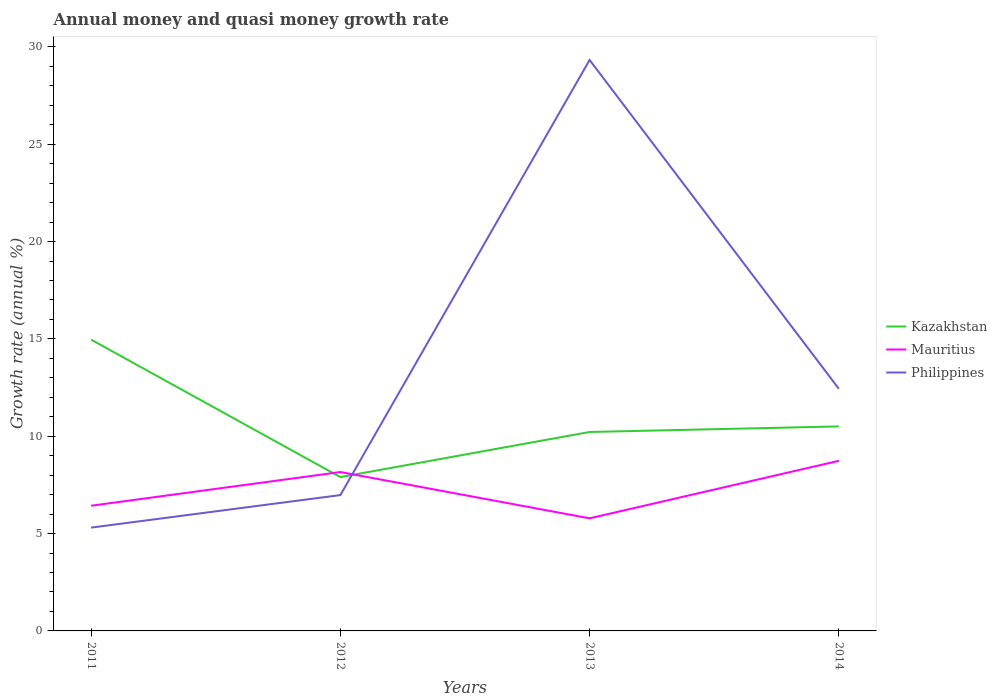Does the line corresponding to Kazakhstan intersect with the line corresponding to Mauritius?
Your answer should be very brief. Yes. Across all years, what is the maximum growth rate in Kazakhstan?
Give a very brief answer. 7.9. What is the total growth rate in Mauritius in the graph?
Ensure brevity in your answer.  -0.58. What is the difference between the highest and the second highest growth rate in Kazakhstan?
Offer a very short reply. 7.06. What is the difference between the highest and the lowest growth rate in Philippines?
Your answer should be very brief. 1. Is the growth rate in Mauritius strictly greater than the growth rate in Philippines over the years?
Keep it short and to the point. No. How many years are there in the graph?
Provide a succinct answer. 4. What is the difference between two consecutive major ticks on the Y-axis?
Your answer should be compact. 5. Are the values on the major ticks of Y-axis written in scientific E-notation?
Provide a succinct answer. No. Where does the legend appear in the graph?
Your answer should be very brief. Center right. What is the title of the graph?
Ensure brevity in your answer.  Annual money and quasi money growth rate. What is the label or title of the X-axis?
Provide a succinct answer. Years. What is the label or title of the Y-axis?
Give a very brief answer. Growth rate (annual %). What is the Growth rate (annual %) of Kazakhstan in 2011?
Provide a succinct answer. 14.96. What is the Growth rate (annual %) of Mauritius in 2011?
Offer a very short reply. 6.43. What is the Growth rate (annual %) of Philippines in 2011?
Your answer should be compact. 5.31. What is the Growth rate (annual %) in Kazakhstan in 2012?
Offer a terse response. 7.9. What is the Growth rate (annual %) of Mauritius in 2012?
Provide a succinct answer. 8.16. What is the Growth rate (annual %) of Philippines in 2012?
Give a very brief answer. 6.98. What is the Growth rate (annual %) in Kazakhstan in 2013?
Ensure brevity in your answer.  10.22. What is the Growth rate (annual %) in Mauritius in 2013?
Offer a terse response. 5.78. What is the Growth rate (annual %) of Philippines in 2013?
Your answer should be compact. 29.33. What is the Growth rate (annual %) of Kazakhstan in 2014?
Offer a very short reply. 10.51. What is the Growth rate (annual %) of Mauritius in 2014?
Offer a terse response. 8.74. What is the Growth rate (annual %) of Philippines in 2014?
Your answer should be compact. 12.44. Across all years, what is the maximum Growth rate (annual %) in Kazakhstan?
Your answer should be very brief. 14.96. Across all years, what is the maximum Growth rate (annual %) in Mauritius?
Your answer should be very brief. 8.74. Across all years, what is the maximum Growth rate (annual %) in Philippines?
Ensure brevity in your answer.  29.33. Across all years, what is the minimum Growth rate (annual %) of Kazakhstan?
Your answer should be compact. 7.9. Across all years, what is the minimum Growth rate (annual %) in Mauritius?
Keep it short and to the point. 5.78. Across all years, what is the minimum Growth rate (annual %) of Philippines?
Provide a succinct answer. 5.31. What is the total Growth rate (annual %) in Kazakhstan in the graph?
Make the answer very short. 43.59. What is the total Growth rate (annual %) in Mauritius in the graph?
Your answer should be compact. 29.11. What is the total Growth rate (annual %) in Philippines in the graph?
Your answer should be very brief. 54.05. What is the difference between the Growth rate (annual %) in Kazakhstan in 2011 and that in 2012?
Offer a very short reply. 7.06. What is the difference between the Growth rate (annual %) of Mauritius in 2011 and that in 2012?
Make the answer very short. -1.73. What is the difference between the Growth rate (annual %) in Philippines in 2011 and that in 2012?
Provide a short and direct response. -1.67. What is the difference between the Growth rate (annual %) in Kazakhstan in 2011 and that in 2013?
Keep it short and to the point. 4.75. What is the difference between the Growth rate (annual %) in Mauritius in 2011 and that in 2013?
Keep it short and to the point. 0.65. What is the difference between the Growth rate (annual %) in Philippines in 2011 and that in 2013?
Make the answer very short. -24.02. What is the difference between the Growth rate (annual %) of Kazakhstan in 2011 and that in 2014?
Offer a very short reply. 4.46. What is the difference between the Growth rate (annual %) in Mauritius in 2011 and that in 2014?
Offer a very short reply. -2.31. What is the difference between the Growth rate (annual %) of Philippines in 2011 and that in 2014?
Provide a succinct answer. -7.13. What is the difference between the Growth rate (annual %) in Kazakhstan in 2012 and that in 2013?
Keep it short and to the point. -2.32. What is the difference between the Growth rate (annual %) in Mauritius in 2012 and that in 2013?
Offer a terse response. 2.38. What is the difference between the Growth rate (annual %) of Philippines in 2012 and that in 2013?
Ensure brevity in your answer.  -22.35. What is the difference between the Growth rate (annual %) in Kazakhstan in 2012 and that in 2014?
Provide a succinct answer. -2.6. What is the difference between the Growth rate (annual %) of Mauritius in 2012 and that in 2014?
Offer a terse response. -0.58. What is the difference between the Growth rate (annual %) of Philippines in 2012 and that in 2014?
Ensure brevity in your answer.  -5.46. What is the difference between the Growth rate (annual %) in Kazakhstan in 2013 and that in 2014?
Provide a short and direct response. -0.29. What is the difference between the Growth rate (annual %) in Mauritius in 2013 and that in 2014?
Keep it short and to the point. -2.95. What is the difference between the Growth rate (annual %) in Philippines in 2013 and that in 2014?
Keep it short and to the point. 16.89. What is the difference between the Growth rate (annual %) in Kazakhstan in 2011 and the Growth rate (annual %) in Mauritius in 2012?
Ensure brevity in your answer.  6.8. What is the difference between the Growth rate (annual %) of Kazakhstan in 2011 and the Growth rate (annual %) of Philippines in 2012?
Keep it short and to the point. 7.99. What is the difference between the Growth rate (annual %) of Mauritius in 2011 and the Growth rate (annual %) of Philippines in 2012?
Offer a terse response. -0.55. What is the difference between the Growth rate (annual %) of Kazakhstan in 2011 and the Growth rate (annual %) of Mauritius in 2013?
Provide a succinct answer. 9.18. What is the difference between the Growth rate (annual %) of Kazakhstan in 2011 and the Growth rate (annual %) of Philippines in 2013?
Your answer should be very brief. -14.37. What is the difference between the Growth rate (annual %) in Mauritius in 2011 and the Growth rate (annual %) in Philippines in 2013?
Your answer should be very brief. -22.9. What is the difference between the Growth rate (annual %) in Kazakhstan in 2011 and the Growth rate (annual %) in Mauritius in 2014?
Offer a terse response. 6.23. What is the difference between the Growth rate (annual %) of Kazakhstan in 2011 and the Growth rate (annual %) of Philippines in 2014?
Your answer should be compact. 2.53. What is the difference between the Growth rate (annual %) of Mauritius in 2011 and the Growth rate (annual %) of Philippines in 2014?
Make the answer very short. -6.01. What is the difference between the Growth rate (annual %) of Kazakhstan in 2012 and the Growth rate (annual %) of Mauritius in 2013?
Provide a short and direct response. 2.12. What is the difference between the Growth rate (annual %) in Kazakhstan in 2012 and the Growth rate (annual %) in Philippines in 2013?
Provide a succinct answer. -21.43. What is the difference between the Growth rate (annual %) of Mauritius in 2012 and the Growth rate (annual %) of Philippines in 2013?
Keep it short and to the point. -21.17. What is the difference between the Growth rate (annual %) in Kazakhstan in 2012 and the Growth rate (annual %) in Mauritius in 2014?
Your answer should be very brief. -0.84. What is the difference between the Growth rate (annual %) in Kazakhstan in 2012 and the Growth rate (annual %) in Philippines in 2014?
Offer a very short reply. -4.54. What is the difference between the Growth rate (annual %) of Mauritius in 2012 and the Growth rate (annual %) of Philippines in 2014?
Your answer should be compact. -4.28. What is the difference between the Growth rate (annual %) in Kazakhstan in 2013 and the Growth rate (annual %) in Mauritius in 2014?
Provide a short and direct response. 1.48. What is the difference between the Growth rate (annual %) of Kazakhstan in 2013 and the Growth rate (annual %) of Philippines in 2014?
Ensure brevity in your answer.  -2.22. What is the difference between the Growth rate (annual %) of Mauritius in 2013 and the Growth rate (annual %) of Philippines in 2014?
Keep it short and to the point. -6.65. What is the average Growth rate (annual %) in Kazakhstan per year?
Your answer should be compact. 10.9. What is the average Growth rate (annual %) of Mauritius per year?
Ensure brevity in your answer.  7.28. What is the average Growth rate (annual %) of Philippines per year?
Provide a short and direct response. 13.51. In the year 2011, what is the difference between the Growth rate (annual %) in Kazakhstan and Growth rate (annual %) in Mauritius?
Offer a very short reply. 8.53. In the year 2011, what is the difference between the Growth rate (annual %) in Kazakhstan and Growth rate (annual %) in Philippines?
Give a very brief answer. 9.66. In the year 2011, what is the difference between the Growth rate (annual %) of Mauritius and Growth rate (annual %) of Philippines?
Your response must be concise. 1.12. In the year 2012, what is the difference between the Growth rate (annual %) in Kazakhstan and Growth rate (annual %) in Mauritius?
Offer a very short reply. -0.26. In the year 2012, what is the difference between the Growth rate (annual %) in Kazakhstan and Growth rate (annual %) in Philippines?
Keep it short and to the point. 0.92. In the year 2012, what is the difference between the Growth rate (annual %) of Mauritius and Growth rate (annual %) of Philippines?
Provide a short and direct response. 1.18. In the year 2013, what is the difference between the Growth rate (annual %) of Kazakhstan and Growth rate (annual %) of Mauritius?
Your response must be concise. 4.43. In the year 2013, what is the difference between the Growth rate (annual %) of Kazakhstan and Growth rate (annual %) of Philippines?
Ensure brevity in your answer.  -19.11. In the year 2013, what is the difference between the Growth rate (annual %) in Mauritius and Growth rate (annual %) in Philippines?
Make the answer very short. -23.55. In the year 2014, what is the difference between the Growth rate (annual %) of Kazakhstan and Growth rate (annual %) of Mauritius?
Offer a terse response. 1.77. In the year 2014, what is the difference between the Growth rate (annual %) in Kazakhstan and Growth rate (annual %) in Philippines?
Ensure brevity in your answer.  -1.93. In the year 2014, what is the difference between the Growth rate (annual %) of Mauritius and Growth rate (annual %) of Philippines?
Give a very brief answer. -3.7. What is the ratio of the Growth rate (annual %) in Kazakhstan in 2011 to that in 2012?
Offer a very short reply. 1.89. What is the ratio of the Growth rate (annual %) of Mauritius in 2011 to that in 2012?
Provide a succinct answer. 0.79. What is the ratio of the Growth rate (annual %) in Philippines in 2011 to that in 2012?
Keep it short and to the point. 0.76. What is the ratio of the Growth rate (annual %) of Kazakhstan in 2011 to that in 2013?
Provide a short and direct response. 1.46. What is the ratio of the Growth rate (annual %) in Mauritius in 2011 to that in 2013?
Your answer should be compact. 1.11. What is the ratio of the Growth rate (annual %) of Philippines in 2011 to that in 2013?
Provide a short and direct response. 0.18. What is the ratio of the Growth rate (annual %) in Kazakhstan in 2011 to that in 2014?
Offer a terse response. 1.42. What is the ratio of the Growth rate (annual %) in Mauritius in 2011 to that in 2014?
Provide a short and direct response. 0.74. What is the ratio of the Growth rate (annual %) of Philippines in 2011 to that in 2014?
Give a very brief answer. 0.43. What is the ratio of the Growth rate (annual %) of Kazakhstan in 2012 to that in 2013?
Your answer should be very brief. 0.77. What is the ratio of the Growth rate (annual %) in Mauritius in 2012 to that in 2013?
Keep it short and to the point. 1.41. What is the ratio of the Growth rate (annual %) in Philippines in 2012 to that in 2013?
Make the answer very short. 0.24. What is the ratio of the Growth rate (annual %) in Kazakhstan in 2012 to that in 2014?
Provide a succinct answer. 0.75. What is the ratio of the Growth rate (annual %) of Mauritius in 2012 to that in 2014?
Make the answer very short. 0.93. What is the ratio of the Growth rate (annual %) in Philippines in 2012 to that in 2014?
Provide a succinct answer. 0.56. What is the ratio of the Growth rate (annual %) of Kazakhstan in 2013 to that in 2014?
Your response must be concise. 0.97. What is the ratio of the Growth rate (annual %) of Mauritius in 2013 to that in 2014?
Offer a very short reply. 0.66. What is the ratio of the Growth rate (annual %) of Philippines in 2013 to that in 2014?
Your answer should be compact. 2.36. What is the difference between the highest and the second highest Growth rate (annual %) of Kazakhstan?
Give a very brief answer. 4.46. What is the difference between the highest and the second highest Growth rate (annual %) in Mauritius?
Give a very brief answer. 0.58. What is the difference between the highest and the second highest Growth rate (annual %) of Philippines?
Provide a succinct answer. 16.89. What is the difference between the highest and the lowest Growth rate (annual %) of Kazakhstan?
Your answer should be compact. 7.06. What is the difference between the highest and the lowest Growth rate (annual %) in Mauritius?
Ensure brevity in your answer.  2.95. What is the difference between the highest and the lowest Growth rate (annual %) in Philippines?
Provide a short and direct response. 24.02. 